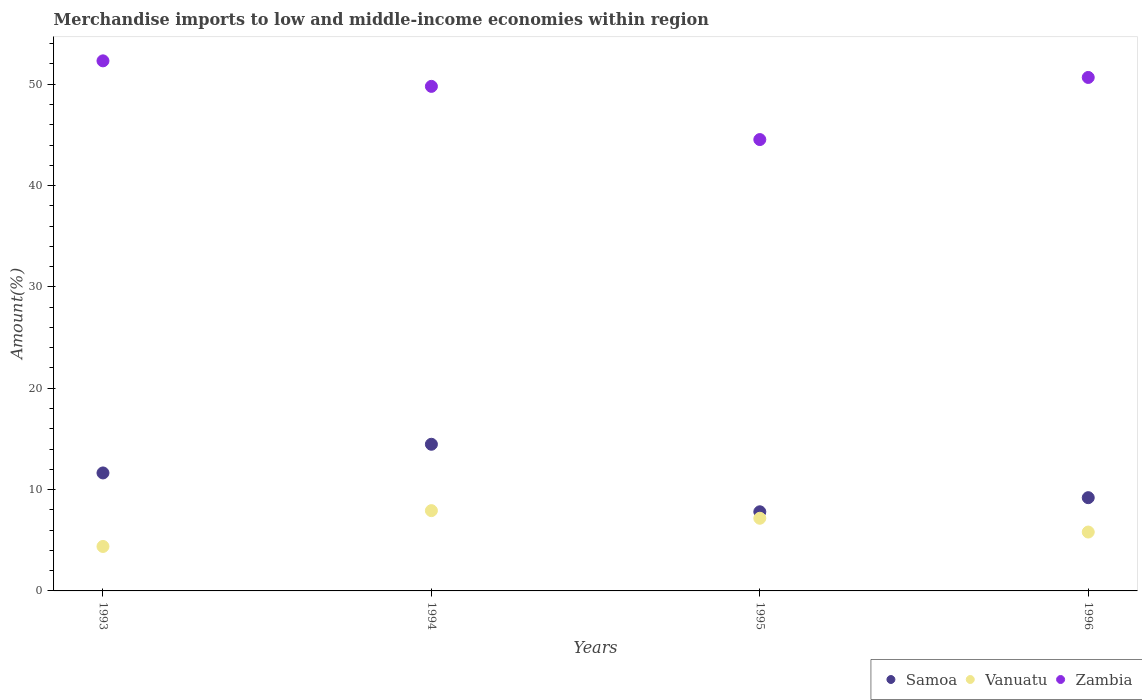How many different coloured dotlines are there?
Your response must be concise. 3. Is the number of dotlines equal to the number of legend labels?
Your answer should be compact. Yes. What is the percentage of amount earned from merchandise imports in Vanuatu in 1994?
Your answer should be very brief. 7.92. Across all years, what is the maximum percentage of amount earned from merchandise imports in Samoa?
Keep it short and to the point. 14.47. Across all years, what is the minimum percentage of amount earned from merchandise imports in Zambia?
Offer a terse response. 44.54. What is the total percentage of amount earned from merchandise imports in Zambia in the graph?
Your answer should be compact. 197.29. What is the difference between the percentage of amount earned from merchandise imports in Zambia in 1993 and that in 1994?
Offer a very short reply. 2.52. What is the difference between the percentage of amount earned from merchandise imports in Zambia in 1994 and the percentage of amount earned from merchandise imports in Samoa in 1995?
Keep it short and to the point. 41.98. What is the average percentage of amount earned from merchandise imports in Samoa per year?
Make the answer very short. 10.78. In the year 1994, what is the difference between the percentage of amount earned from merchandise imports in Samoa and percentage of amount earned from merchandise imports in Zambia?
Provide a short and direct response. -35.32. In how many years, is the percentage of amount earned from merchandise imports in Samoa greater than 48 %?
Provide a succinct answer. 0. What is the ratio of the percentage of amount earned from merchandise imports in Vanuatu in 1993 to that in 1996?
Ensure brevity in your answer.  0.76. Is the percentage of amount earned from merchandise imports in Samoa in 1995 less than that in 1996?
Offer a very short reply. Yes. Is the difference between the percentage of amount earned from merchandise imports in Samoa in 1994 and 1996 greater than the difference between the percentage of amount earned from merchandise imports in Zambia in 1994 and 1996?
Your response must be concise. Yes. What is the difference between the highest and the second highest percentage of amount earned from merchandise imports in Samoa?
Ensure brevity in your answer.  2.83. What is the difference between the highest and the lowest percentage of amount earned from merchandise imports in Samoa?
Keep it short and to the point. 6.66. Is it the case that in every year, the sum of the percentage of amount earned from merchandise imports in Samoa and percentage of amount earned from merchandise imports in Vanuatu  is greater than the percentage of amount earned from merchandise imports in Zambia?
Ensure brevity in your answer.  No. Is the percentage of amount earned from merchandise imports in Vanuatu strictly less than the percentage of amount earned from merchandise imports in Samoa over the years?
Ensure brevity in your answer.  Yes. Are the values on the major ticks of Y-axis written in scientific E-notation?
Make the answer very short. No. Does the graph contain any zero values?
Make the answer very short. No. Where does the legend appear in the graph?
Provide a short and direct response. Bottom right. How many legend labels are there?
Your response must be concise. 3. What is the title of the graph?
Offer a very short reply. Merchandise imports to low and middle-income economies within region. Does "Azerbaijan" appear as one of the legend labels in the graph?
Ensure brevity in your answer.  No. What is the label or title of the X-axis?
Keep it short and to the point. Years. What is the label or title of the Y-axis?
Your response must be concise. Amount(%). What is the Amount(%) in Samoa in 1993?
Offer a terse response. 11.64. What is the Amount(%) in Vanuatu in 1993?
Your response must be concise. 4.39. What is the Amount(%) of Zambia in 1993?
Ensure brevity in your answer.  52.3. What is the Amount(%) of Samoa in 1994?
Offer a terse response. 14.47. What is the Amount(%) of Vanuatu in 1994?
Your answer should be compact. 7.92. What is the Amount(%) of Zambia in 1994?
Provide a succinct answer. 49.79. What is the Amount(%) in Samoa in 1995?
Give a very brief answer. 7.81. What is the Amount(%) of Vanuatu in 1995?
Keep it short and to the point. 7.17. What is the Amount(%) of Zambia in 1995?
Your answer should be compact. 44.54. What is the Amount(%) of Samoa in 1996?
Provide a short and direct response. 9.2. What is the Amount(%) in Vanuatu in 1996?
Your response must be concise. 5.81. What is the Amount(%) of Zambia in 1996?
Offer a very short reply. 50.67. Across all years, what is the maximum Amount(%) in Samoa?
Ensure brevity in your answer.  14.47. Across all years, what is the maximum Amount(%) of Vanuatu?
Provide a short and direct response. 7.92. Across all years, what is the maximum Amount(%) in Zambia?
Provide a short and direct response. 52.3. Across all years, what is the minimum Amount(%) of Samoa?
Provide a succinct answer. 7.81. Across all years, what is the minimum Amount(%) in Vanuatu?
Offer a very short reply. 4.39. Across all years, what is the minimum Amount(%) of Zambia?
Keep it short and to the point. 44.54. What is the total Amount(%) in Samoa in the graph?
Offer a terse response. 43.12. What is the total Amount(%) of Vanuatu in the graph?
Offer a very short reply. 25.29. What is the total Amount(%) in Zambia in the graph?
Your answer should be compact. 197.29. What is the difference between the Amount(%) in Samoa in 1993 and that in 1994?
Provide a short and direct response. -2.83. What is the difference between the Amount(%) in Vanuatu in 1993 and that in 1994?
Your answer should be very brief. -3.54. What is the difference between the Amount(%) of Zambia in 1993 and that in 1994?
Your answer should be compact. 2.52. What is the difference between the Amount(%) in Samoa in 1993 and that in 1995?
Offer a terse response. 3.83. What is the difference between the Amount(%) of Vanuatu in 1993 and that in 1995?
Your response must be concise. -2.78. What is the difference between the Amount(%) of Zambia in 1993 and that in 1995?
Provide a short and direct response. 7.77. What is the difference between the Amount(%) of Samoa in 1993 and that in 1996?
Your response must be concise. 2.44. What is the difference between the Amount(%) in Vanuatu in 1993 and that in 1996?
Provide a succinct answer. -1.42. What is the difference between the Amount(%) in Zambia in 1993 and that in 1996?
Your answer should be compact. 1.64. What is the difference between the Amount(%) in Samoa in 1994 and that in 1995?
Offer a very short reply. 6.66. What is the difference between the Amount(%) in Vanuatu in 1994 and that in 1995?
Give a very brief answer. 0.75. What is the difference between the Amount(%) of Zambia in 1994 and that in 1995?
Your answer should be compact. 5.25. What is the difference between the Amount(%) in Samoa in 1994 and that in 1996?
Your answer should be very brief. 5.27. What is the difference between the Amount(%) of Vanuatu in 1994 and that in 1996?
Offer a very short reply. 2.11. What is the difference between the Amount(%) of Zambia in 1994 and that in 1996?
Your answer should be very brief. -0.88. What is the difference between the Amount(%) of Samoa in 1995 and that in 1996?
Provide a short and direct response. -1.39. What is the difference between the Amount(%) of Vanuatu in 1995 and that in 1996?
Keep it short and to the point. 1.36. What is the difference between the Amount(%) of Zambia in 1995 and that in 1996?
Your response must be concise. -6.13. What is the difference between the Amount(%) in Samoa in 1993 and the Amount(%) in Vanuatu in 1994?
Provide a short and direct response. 3.72. What is the difference between the Amount(%) in Samoa in 1993 and the Amount(%) in Zambia in 1994?
Your response must be concise. -38.14. What is the difference between the Amount(%) of Vanuatu in 1993 and the Amount(%) of Zambia in 1994?
Your response must be concise. -45.4. What is the difference between the Amount(%) of Samoa in 1993 and the Amount(%) of Vanuatu in 1995?
Offer a very short reply. 4.47. What is the difference between the Amount(%) in Samoa in 1993 and the Amount(%) in Zambia in 1995?
Ensure brevity in your answer.  -32.9. What is the difference between the Amount(%) in Vanuatu in 1993 and the Amount(%) in Zambia in 1995?
Offer a very short reply. -40.15. What is the difference between the Amount(%) in Samoa in 1993 and the Amount(%) in Vanuatu in 1996?
Your answer should be very brief. 5.83. What is the difference between the Amount(%) in Samoa in 1993 and the Amount(%) in Zambia in 1996?
Offer a very short reply. -39.02. What is the difference between the Amount(%) in Vanuatu in 1993 and the Amount(%) in Zambia in 1996?
Ensure brevity in your answer.  -46.28. What is the difference between the Amount(%) of Samoa in 1994 and the Amount(%) of Vanuatu in 1995?
Your response must be concise. 7.3. What is the difference between the Amount(%) of Samoa in 1994 and the Amount(%) of Zambia in 1995?
Provide a short and direct response. -30.07. What is the difference between the Amount(%) of Vanuatu in 1994 and the Amount(%) of Zambia in 1995?
Keep it short and to the point. -36.62. What is the difference between the Amount(%) of Samoa in 1994 and the Amount(%) of Vanuatu in 1996?
Make the answer very short. 8.66. What is the difference between the Amount(%) in Samoa in 1994 and the Amount(%) in Zambia in 1996?
Offer a very short reply. -36.2. What is the difference between the Amount(%) of Vanuatu in 1994 and the Amount(%) of Zambia in 1996?
Keep it short and to the point. -42.74. What is the difference between the Amount(%) of Samoa in 1995 and the Amount(%) of Vanuatu in 1996?
Offer a very short reply. 2. What is the difference between the Amount(%) in Samoa in 1995 and the Amount(%) in Zambia in 1996?
Offer a very short reply. -42.86. What is the difference between the Amount(%) in Vanuatu in 1995 and the Amount(%) in Zambia in 1996?
Keep it short and to the point. -43.5. What is the average Amount(%) of Samoa per year?
Your answer should be compact. 10.78. What is the average Amount(%) of Vanuatu per year?
Your answer should be compact. 6.32. What is the average Amount(%) in Zambia per year?
Keep it short and to the point. 49.32. In the year 1993, what is the difference between the Amount(%) of Samoa and Amount(%) of Vanuatu?
Offer a very short reply. 7.26. In the year 1993, what is the difference between the Amount(%) in Samoa and Amount(%) in Zambia?
Offer a very short reply. -40.66. In the year 1993, what is the difference between the Amount(%) in Vanuatu and Amount(%) in Zambia?
Your answer should be compact. -47.92. In the year 1994, what is the difference between the Amount(%) in Samoa and Amount(%) in Vanuatu?
Ensure brevity in your answer.  6.55. In the year 1994, what is the difference between the Amount(%) in Samoa and Amount(%) in Zambia?
Give a very brief answer. -35.32. In the year 1994, what is the difference between the Amount(%) of Vanuatu and Amount(%) of Zambia?
Give a very brief answer. -41.86. In the year 1995, what is the difference between the Amount(%) of Samoa and Amount(%) of Vanuatu?
Ensure brevity in your answer.  0.64. In the year 1995, what is the difference between the Amount(%) in Samoa and Amount(%) in Zambia?
Give a very brief answer. -36.73. In the year 1995, what is the difference between the Amount(%) in Vanuatu and Amount(%) in Zambia?
Your response must be concise. -37.37. In the year 1996, what is the difference between the Amount(%) in Samoa and Amount(%) in Vanuatu?
Provide a short and direct response. 3.39. In the year 1996, what is the difference between the Amount(%) of Samoa and Amount(%) of Zambia?
Offer a very short reply. -41.46. In the year 1996, what is the difference between the Amount(%) of Vanuatu and Amount(%) of Zambia?
Ensure brevity in your answer.  -44.86. What is the ratio of the Amount(%) in Samoa in 1993 to that in 1994?
Provide a succinct answer. 0.8. What is the ratio of the Amount(%) in Vanuatu in 1993 to that in 1994?
Your answer should be compact. 0.55. What is the ratio of the Amount(%) in Zambia in 1993 to that in 1994?
Your answer should be compact. 1.05. What is the ratio of the Amount(%) in Samoa in 1993 to that in 1995?
Give a very brief answer. 1.49. What is the ratio of the Amount(%) in Vanuatu in 1993 to that in 1995?
Your answer should be very brief. 0.61. What is the ratio of the Amount(%) of Zambia in 1993 to that in 1995?
Offer a terse response. 1.17. What is the ratio of the Amount(%) in Samoa in 1993 to that in 1996?
Provide a short and direct response. 1.27. What is the ratio of the Amount(%) in Vanuatu in 1993 to that in 1996?
Provide a short and direct response. 0.76. What is the ratio of the Amount(%) of Zambia in 1993 to that in 1996?
Your answer should be very brief. 1.03. What is the ratio of the Amount(%) of Samoa in 1994 to that in 1995?
Ensure brevity in your answer.  1.85. What is the ratio of the Amount(%) in Vanuatu in 1994 to that in 1995?
Provide a succinct answer. 1.1. What is the ratio of the Amount(%) of Zambia in 1994 to that in 1995?
Make the answer very short. 1.12. What is the ratio of the Amount(%) of Samoa in 1994 to that in 1996?
Keep it short and to the point. 1.57. What is the ratio of the Amount(%) in Vanuatu in 1994 to that in 1996?
Your answer should be very brief. 1.36. What is the ratio of the Amount(%) in Zambia in 1994 to that in 1996?
Offer a very short reply. 0.98. What is the ratio of the Amount(%) in Samoa in 1995 to that in 1996?
Offer a very short reply. 0.85. What is the ratio of the Amount(%) in Vanuatu in 1995 to that in 1996?
Make the answer very short. 1.23. What is the ratio of the Amount(%) in Zambia in 1995 to that in 1996?
Give a very brief answer. 0.88. What is the difference between the highest and the second highest Amount(%) of Samoa?
Offer a very short reply. 2.83. What is the difference between the highest and the second highest Amount(%) in Vanuatu?
Your answer should be very brief. 0.75. What is the difference between the highest and the second highest Amount(%) of Zambia?
Make the answer very short. 1.64. What is the difference between the highest and the lowest Amount(%) of Samoa?
Your answer should be compact. 6.66. What is the difference between the highest and the lowest Amount(%) in Vanuatu?
Your answer should be very brief. 3.54. What is the difference between the highest and the lowest Amount(%) in Zambia?
Offer a very short reply. 7.77. 